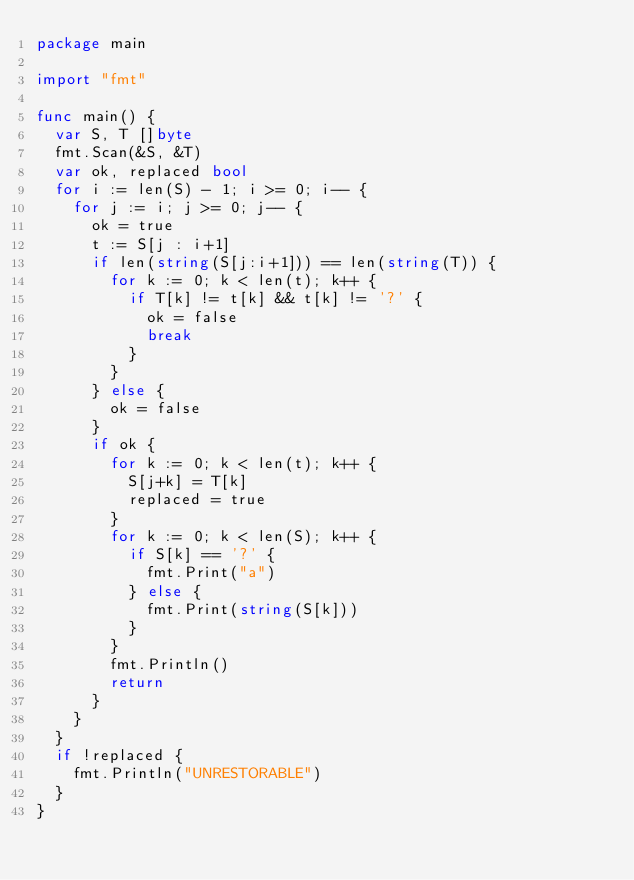Convert code to text. <code><loc_0><loc_0><loc_500><loc_500><_Go_>package main

import "fmt"

func main() {
	var S, T []byte
	fmt.Scan(&S, &T)
	var ok, replaced bool
	for i := len(S) - 1; i >= 0; i-- {
		for j := i; j >= 0; j-- {
			ok = true
			t := S[j : i+1]
			if len(string(S[j:i+1])) == len(string(T)) {
				for k := 0; k < len(t); k++ {
					if T[k] != t[k] && t[k] != '?' {
						ok = false
						break
					}
				}
			} else {
				ok = false
			}
			if ok {
				for k := 0; k < len(t); k++ {
					S[j+k] = T[k]
					replaced = true
				}
				for k := 0; k < len(S); k++ {
					if S[k] == '?' {
						fmt.Print("a")
					} else {
						fmt.Print(string(S[k]))
					}
				}
				fmt.Println()
				return
			}
		}
	}
	if !replaced {
		fmt.Println("UNRESTORABLE")
	}
}
</code> 